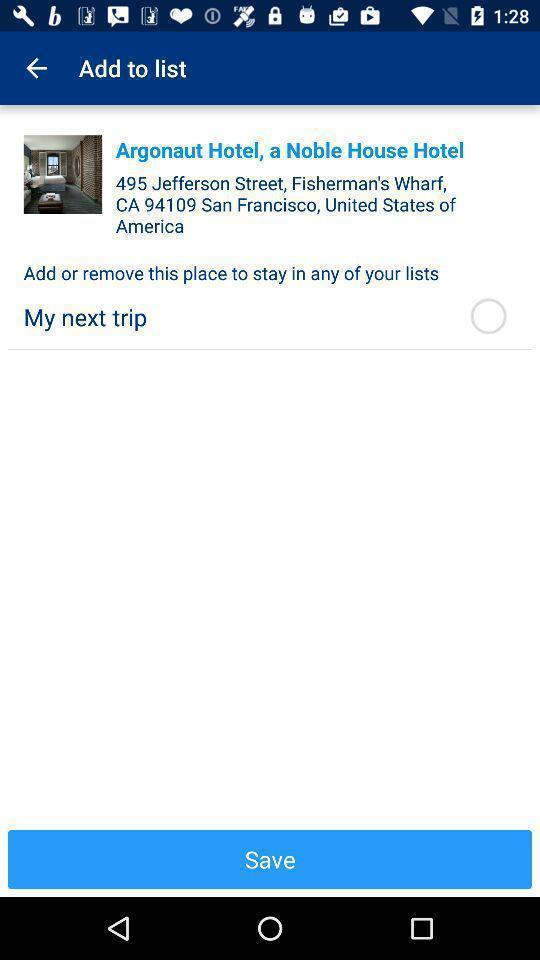Summarize the main components in this picture. Page showing the add to list category. 